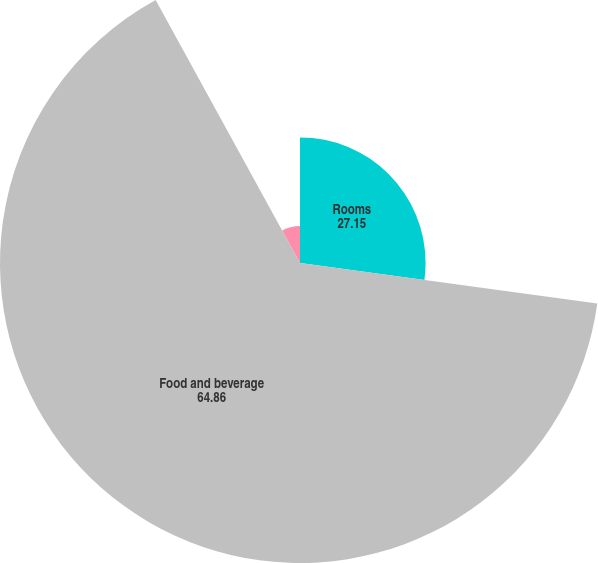Convert chart to OTSL. <chart><loc_0><loc_0><loc_500><loc_500><pie_chart><fcel>Rooms<fcel>Food and beverage<fcel>Entertainment retail and other<nl><fcel>27.15%<fcel>64.86%<fcel>7.99%<nl></chart> 